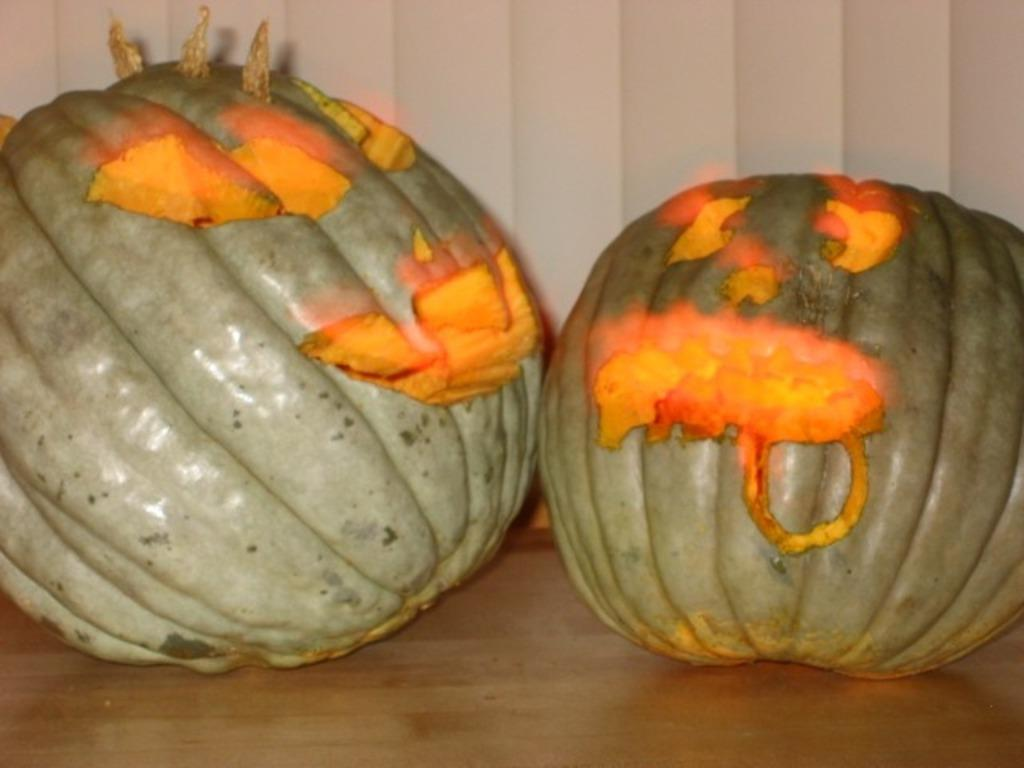What type of objects are present on the table in the image? There are pumpkins on the table in the image. Can you describe the location of the pumpkins in the image? The pumpkins are placed on a table. What type of metal can be seen in the image? There is no metal present in the image; it features pumpkins on a table. What type of vegetation is growing around the pumpkins in the image? There is no vegetation mentioned in the image; it only features pumpkins on a table. 